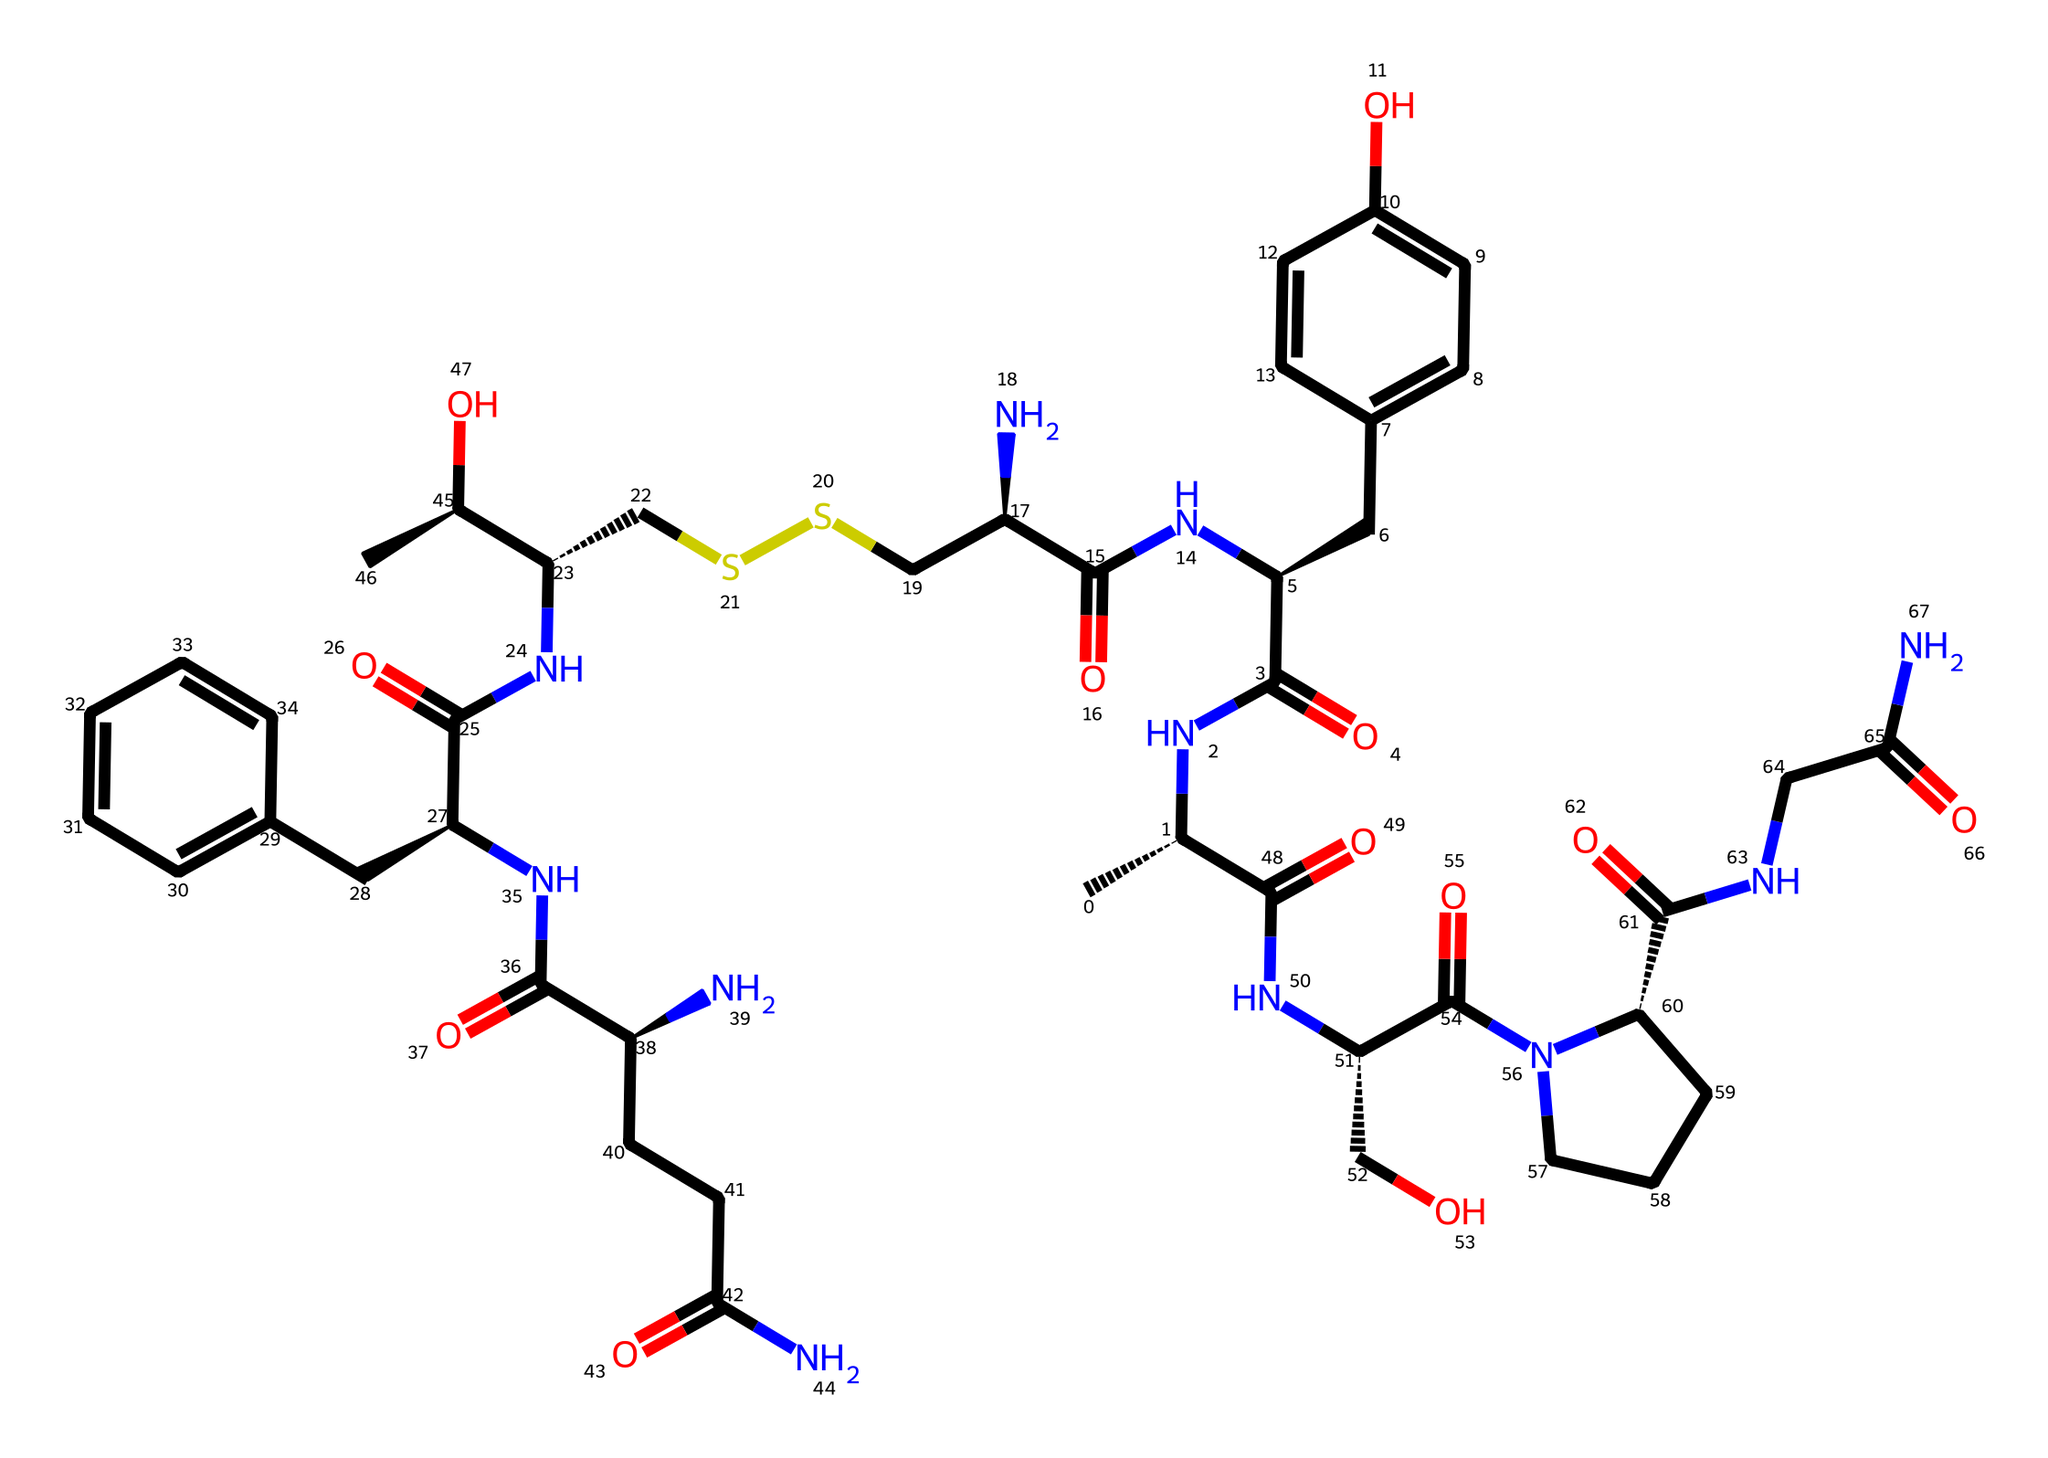What is the name of this chemical? The SMILES representation indicates that this chemical is oxytocin, a known peptide hormone. The specific arrangement of the atoms and the presence of characteristic functional groups also confirm its identity.
Answer: oxytocin How many nitrogen atoms does oxytocin contain? By examining the SMILES representation, we identify four nitrogen atoms (N) present in the sequence. Each nitrogen is clearly indicated in the structure.
Answer: four What type of chemical does oxytocin belong to? Oxytocin is classified as a peptide hormone due to its structure made up of amino acids linked by peptide bonds. The presence of several amide groups (indicated by NC(=O)) also supports this classification.
Answer: peptide hormone How many carbon atoms are present in oxytocin? Counting the carbon atoms (C) in the SMILES representation shows a total of 30 carbon atoms, as they are enumerated throughout the structure.
Answer: thirty What functional groups are present in oxytocin? The main functional groups in oxytocin include amide (C(=O)N), alcohol (C(OH)), and disulfide (CSSC). These functional groups are represented throughout the structure in the SMILES notation.
Answer: amide, alcohol, disulfide How many rings are in the structure of oxytocin? Reviewing the SMILES representation, there are two cyclic structures present, which can be identified by the notation of ring closings (the use of numbers indicates rings).
Answer: two 